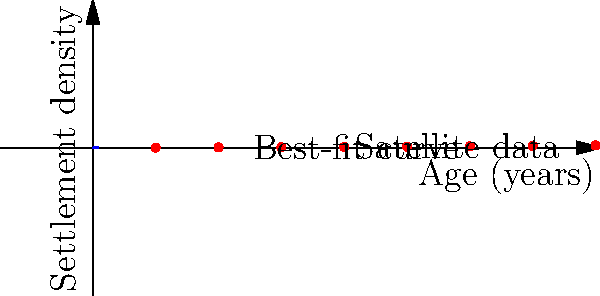Based on the graph showing the relationship between settlement age and density derived from satellite imagery and terrain data, what mathematical model best describes the growth of Sámi settlement density over time, and what does this imply about the historical development of these settlements? To answer this question, let's analyze the graph step-by-step:

1. Observe the data points: The red dots represent actual data from satellite imagery and terrain analysis of Sámi settlements.

2. Notice the curve: A blue curve is fitted to these data points, representing the best-fit model.

3. Analyze the shape: The curve appears to be increasing at an increasing rate, suggesting exponential growth.

4. Confirm the model: The best-fit curve follows the equation $y = e^{kx}$, where $y$ is the settlement density, $x$ is the age in years, and $k$ is the growth rate constant.

5. Estimate the growth rate: From the graph, we can approximate $k \approx 0.0023$.

6. Express the model: The settlement density ($D$) as a function of age ($t$) can be written as $D(t) = e^{0.0023t}$.

7. Interpret the results: This exponential growth model implies that:
   a) Sámi settlements grew rapidly over time.
   b) The rate of new settlement formation increased as existing settlements expanded.
   c) Factors such as population growth, cultural development, and resource utilization likely contributed to this exponential pattern.

8. Historical implications: This model suggests that Sámi settlement patterns experienced accelerating growth and complexity over the centuries, possibly reflecting advancements in their societal structure, technology, and adaptation to their environment.
Answer: Exponential growth model: $D(t) = e^{0.0023t}$ 